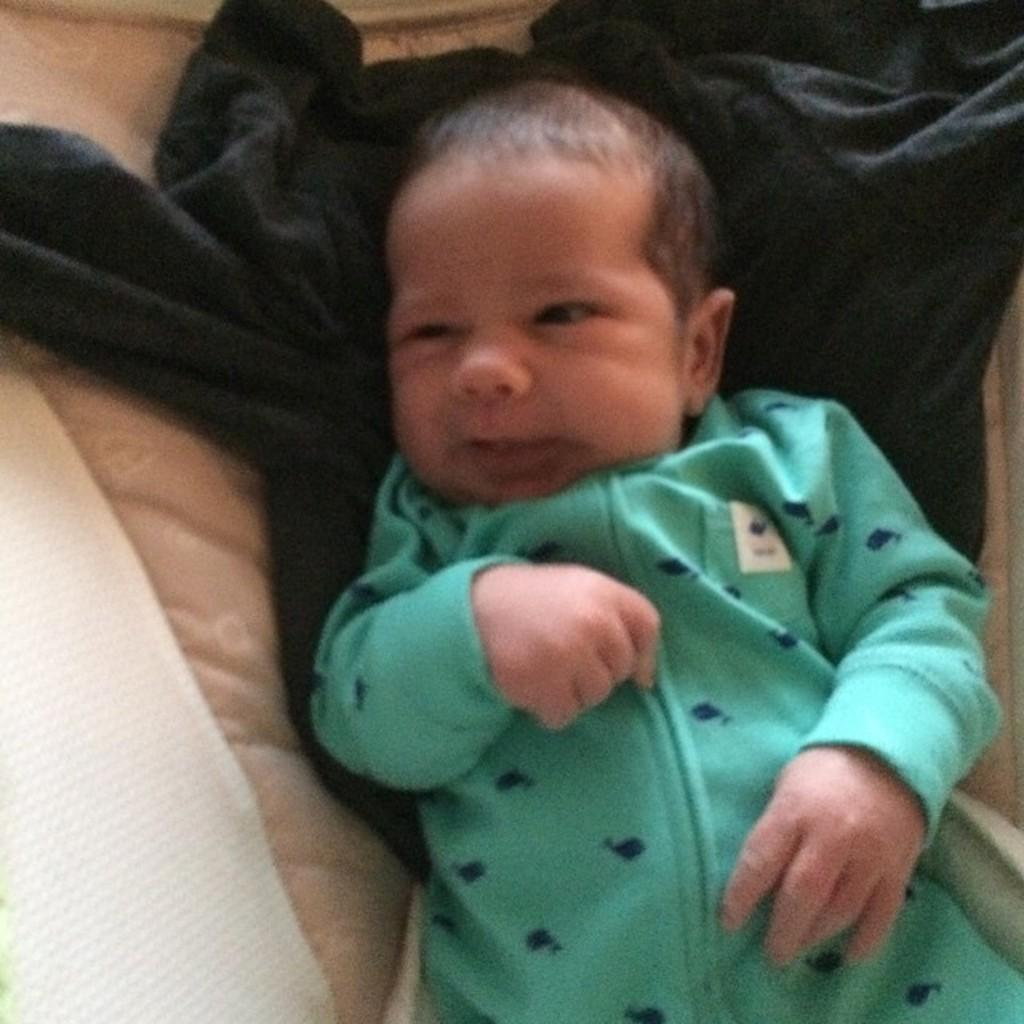What is the main subject of the image? There is a baby in the image. Where is the baby located? The baby is lying on a bed. What is beneath the baby on the bed? There is a cloth beneath the baby. What type of property does the baby own in the image? There is no indication of the baby owning any property in the image. What kind of coat is the baby wearing in the image? The baby is not wearing a coat in the image; they are lying on a bed with a cloth beneath them. 